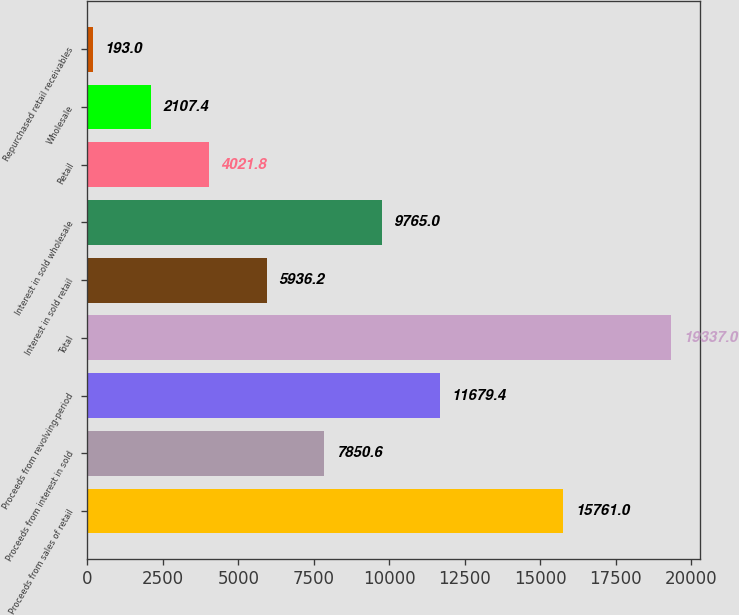Convert chart. <chart><loc_0><loc_0><loc_500><loc_500><bar_chart><fcel>Proceeds from sales of retail<fcel>Proceeds from interest in sold<fcel>Proceeds from revolving-period<fcel>Total<fcel>Interest in sold retail<fcel>Interest in sold wholesale<fcel>Retail<fcel>Wholesale<fcel>Repurchased retail receivables<nl><fcel>15761<fcel>7850.6<fcel>11679.4<fcel>19337<fcel>5936.2<fcel>9765<fcel>4021.8<fcel>2107.4<fcel>193<nl></chart> 